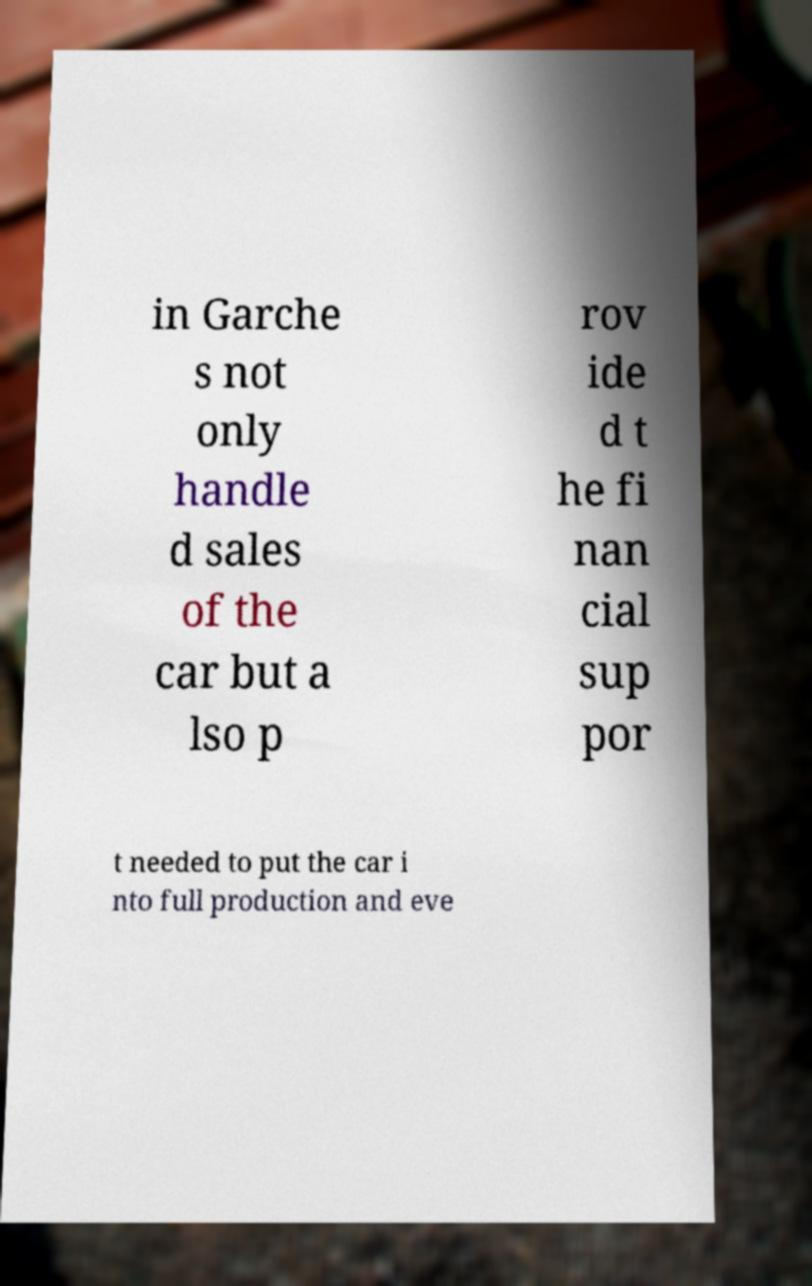What messages or text are displayed in this image? I need them in a readable, typed format. in Garche s not only handle d sales of the car but a lso p rov ide d t he fi nan cial sup por t needed to put the car i nto full production and eve 